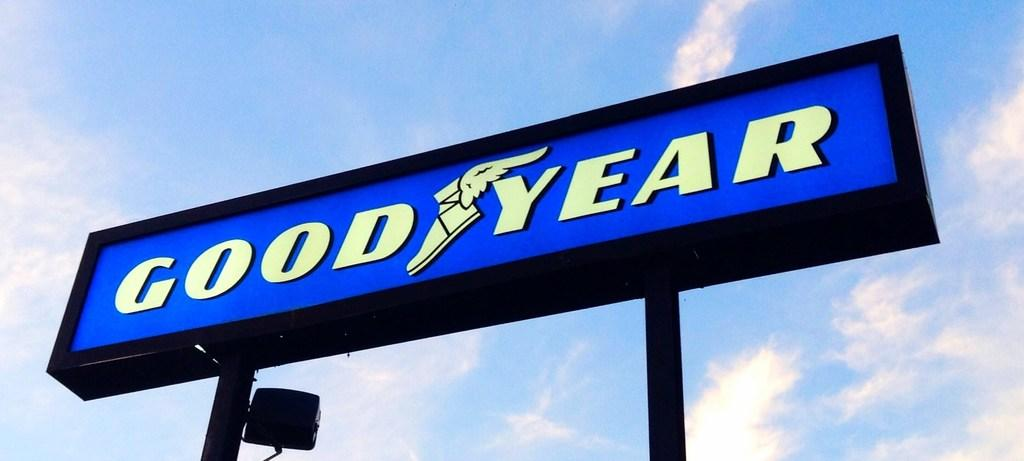<image>
Present a compact description of the photo's key features. a sign that has the word Goodyear on it 